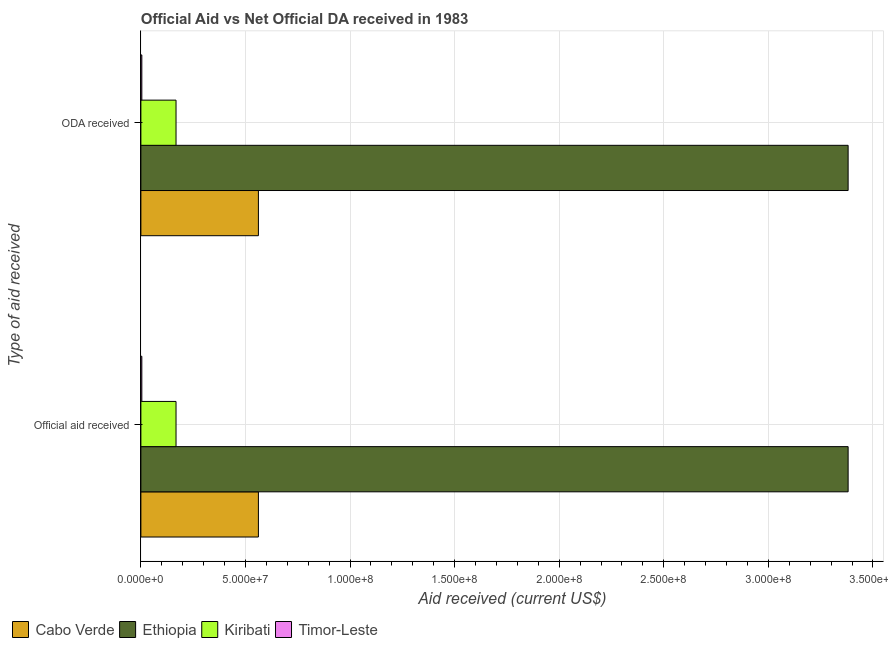How many different coloured bars are there?
Keep it short and to the point. 4. What is the label of the 1st group of bars from the top?
Offer a terse response. ODA received. What is the oda received in Cabo Verde?
Ensure brevity in your answer.  5.62e+07. Across all countries, what is the maximum oda received?
Ensure brevity in your answer.  3.38e+08. Across all countries, what is the minimum oda received?
Provide a succinct answer. 4.50e+05. In which country was the oda received maximum?
Make the answer very short. Ethiopia. In which country was the official aid received minimum?
Give a very brief answer. Timor-Leste. What is the total official aid received in the graph?
Your answer should be compact. 4.12e+08. What is the difference between the oda received in Timor-Leste and that in Ethiopia?
Your answer should be very brief. -3.38e+08. What is the difference between the official aid received in Ethiopia and the oda received in Cabo Verde?
Provide a succinct answer. 2.82e+08. What is the average oda received per country?
Keep it short and to the point. 1.03e+08. What is the ratio of the official aid received in Timor-Leste to that in Cabo Verde?
Provide a short and direct response. 0.01. In how many countries, is the official aid received greater than the average official aid received taken over all countries?
Provide a short and direct response. 1. What does the 4th bar from the top in ODA received represents?
Your answer should be very brief. Cabo Verde. What does the 2nd bar from the bottom in Official aid received represents?
Provide a succinct answer. Ethiopia. How many bars are there?
Keep it short and to the point. 8. How many countries are there in the graph?
Your answer should be very brief. 4. What is the difference between two consecutive major ticks on the X-axis?
Your answer should be compact. 5.00e+07. Does the graph contain grids?
Provide a short and direct response. Yes. Where does the legend appear in the graph?
Offer a terse response. Bottom left. How many legend labels are there?
Offer a terse response. 4. What is the title of the graph?
Provide a short and direct response. Official Aid vs Net Official DA received in 1983 . Does "West Bank and Gaza" appear as one of the legend labels in the graph?
Make the answer very short. No. What is the label or title of the X-axis?
Your response must be concise. Aid received (current US$). What is the label or title of the Y-axis?
Offer a very short reply. Type of aid received. What is the Aid received (current US$) in Cabo Verde in Official aid received?
Provide a succinct answer. 5.62e+07. What is the Aid received (current US$) in Ethiopia in Official aid received?
Make the answer very short. 3.38e+08. What is the Aid received (current US$) in Kiribati in Official aid received?
Keep it short and to the point. 1.68e+07. What is the Aid received (current US$) of Cabo Verde in ODA received?
Provide a succinct answer. 5.62e+07. What is the Aid received (current US$) of Ethiopia in ODA received?
Your answer should be very brief. 3.38e+08. What is the Aid received (current US$) in Kiribati in ODA received?
Ensure brevity in your answer.  1.68e+07. Across all Type of aid received, what is the maximum Aid received (current US$) in Cabo Verde?
Keep it short and to the point. 5.62e+07. Across all Type of aid received, what is the maximum Aid received (current US$) in Ethiopia?
Offer a terse response. 3.38e+08. Across all Type of aid received, what is the maximum Aid received (current US$) in Kiribati?
Offer a terse response. 1.68e+07. Across all Type of aid received, what is the maximum Aid received (current US$) in Timor-Leste?
Offer a terse response. 4.50e+05. Across all Type of aid received, what is the minimum Aid received (current US$) of Cabo Verde?
Provide a succinct answer. 5.62e+07. Across all Type of aid received, what is the minimum Aid received (current US$) in Ethiopia?
Provide a short and direct response. 3.38e+08. Across all Type of aid received, what is the minimum Aid received (current US$) of Kiribati?
Provide a succinct answer. 1.68e+07. What is the total Aid received (current US$) of Cabo Verde in the graph?
Provide a short and direct response. 1.12e+08. What is the total Aid received (current US$) in Ethiopia in the graph?
Ensure brevity in your answer.  6.76e+08. What is the total Aid received (current US$) of Kiribati in the graph?
Offer a very short reply. 3.36e+07. What is the total Aid received (current US$) in Timor-Leste in the graph?
Offer a very short reply. 9.00e+05. What is the difference between the Aid received (current US$) in Kiribati in Official aid received and that in ODA received?
Your answer should be very brief. 0. What is the difference between the Aid received (current US$) of Timor-Leste in Official aid received and that in ODA received?
Make the answer very short. 0. What is the difference between the Aid received (current US$) in Cabo Verde in Official aid received and the Aid received (current US$) in Ethiopia in ODA received?
Give a very brief answer. -2.82e+08. What is the difference between the Aid received (current US$) of Cabo Verde in Official aid received and the Aid received (current US$) of Kiribati in ODA received?
Keep it short and to the point. 3.94e+07. What is the difference between the Aid received (current US$) of Cabo Verde in Official aid received and the Aid received (current US$) of Timor-Leste in ODA received?
Your answer should be very brief. 5.57e+07. What is the difference between the Aid received (current US$) in Ethiopia in Official aid received and the Aid received (current US$) in Kiribati in ODA received?
Provide a succinct answer. 3.21e+08. What is the difference between the Aid received (current US$) in Ethiopia in Official aid received and the Aid received (current US$) in Timor-Leste in ODA received?
Your answer should be compact. 3.38e+08. What is the difference between the Aid received (current US$) of Kiribati in Official aid received and the Aid received (current US$) of Timor-Leste in ODA received?
Ensure brevity in your answer.  1.64e+07. What is the average Aid received (current US$) of Cabo Verde per Type of aid received?
Your answer should be compact. 5.62e+07. What is the average Aid received (current US$) in Ethiopia per Type of aid received?
Offer a terse response. 3.38e+08. What is the average Aid received (current US$) of Kiribati per Type of aid received?
Your answer should be very brief. 1.68e+07. What is the average Aid received (current US$) in Timor-Leste per Type of aid received?
Give a very brief answer. 4.50e+05. What is the difference between the Aid received (current US$) of Cabo Verde and Aid received (current US$) of Ethiopia in Official aid received?
Provide a succinct answer. -2.82e+08. What is the difference between the Aid received (current US$) of Cabo Verde and Aid received (current US$) of Kiribati in Official aid received?
Your answer should be very brief. 3.94e+07. What is the difference between the Aid received (current US$) of Cabo Verde and Aid received (current US$) of Timor-Leste in Official aid received?
Provide a short and direct response. 5.57e+07. What is the difference between the Aid received (current US$) of Ethiopia and Aid received (current US$) of Kiribati in Official aid received?
Keep it short and to the point. 3.21e+08. What is the difference between the Aid received (current US$) of Ethiopia and Aid received (current US$) of Timor-Leste in Official aid received?
Keep it short and to the point. 3.38e+08. What is the difference between the Aid received (current US$) of Kiribati and Aid received (current US$) of Timor-Leste in Official aid received?
Keep it short and to the point. 1.64e+07. What is the difference between the Aid received (current US$) of Cabo Verde and Aid received (current US$) of Ethiopia in ODA received?
Your response must be concise. -2.82e+08. What is the difference between the Aid received (current US$) in Cabo Verde and Aid received (current US$) in Kiribati in ODA received?
Ensure brevity in your answer.  3.94e+07. What is the difference between the Aid received (current US$) in Cabo Verde and Aid received (current US$) in Timor-Leste in ODA received?
Make the answer very short. 5.57e+07. What is the difference between the Aid received (current US$) in Ethiopia and Aid received (current US$) in Kiribati in ODA received?
Your answer should be compact. 3.21e+08. What is the difference between the Aid received (current US$) of Ethiopia and Aid received (current US$) of Timor-Leste in ODA received?
Ensure brevity in your answer.  3.38e+08. What is the difference between the Aid received (current US$) of Kiribati and Aid received (current US$) of Timor-Leste in ODA received?
Offer a very short reply. 1.64e+07. What is the ratio of the Aid received (current US$) of Cabo Verde in Official aid received to that in ODA received?
Keep it short and to the point. 1. What is the ratio of the Aid received (current US$) in Ethiopia in Official aid received to that in ODA received?
Provide a succinct answer. 1. What is the ratio of the Aid received (current US$) of Kiribati in Official aid received to that in ODA received?
Your answer should be very brief. 1. What is the ratio of the Aid received (current US$) of Timor-Leste in Official aid received to that in ODA received?
Your response must be concise. 1. What is the difference between the highest and the second highest Aid received (current US$) of Cabo Verde?
Your answer should be compact. 0. What is the difference between the highest and the second highest Aid received (current US$) of Ethiopia?
Keep it short and to the point. 0. What is the difference between the highest and the second highest Aid received (current US$) in Kiribati?
Ensure brevity in your answer.  0. What is the difference between the highest and the lowest Aid received (current US$) of Ethiopia?
Provide a succinct answer. 0. 